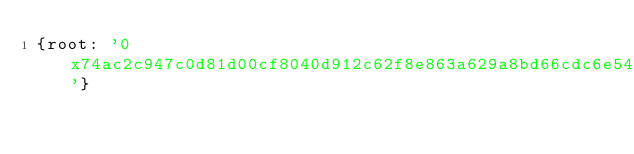Convert code to text. <code><loc_0><loc_0><loc_500><loc_500><_YAML_>{root: '0x74ac2c947c0d81d00cf8040d912c62f8e863a629a8bd66cdc6e5435e141291f9'}
</code> 